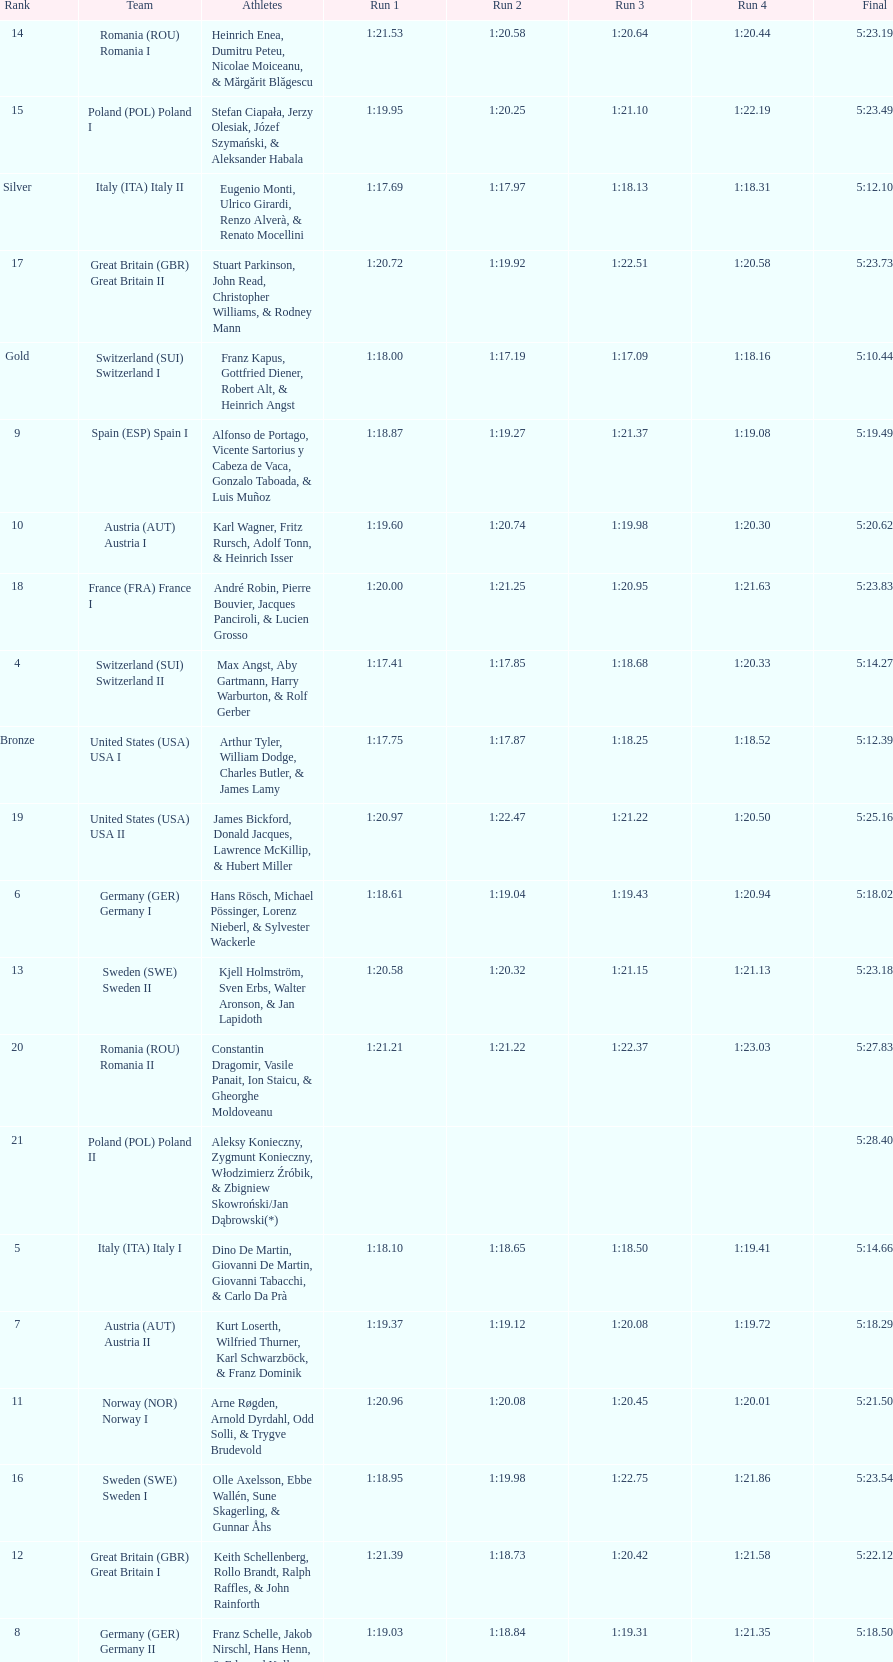Who is the previous team to italy (ita) italy ii? Switzerland (SUI) Switzerland I. 